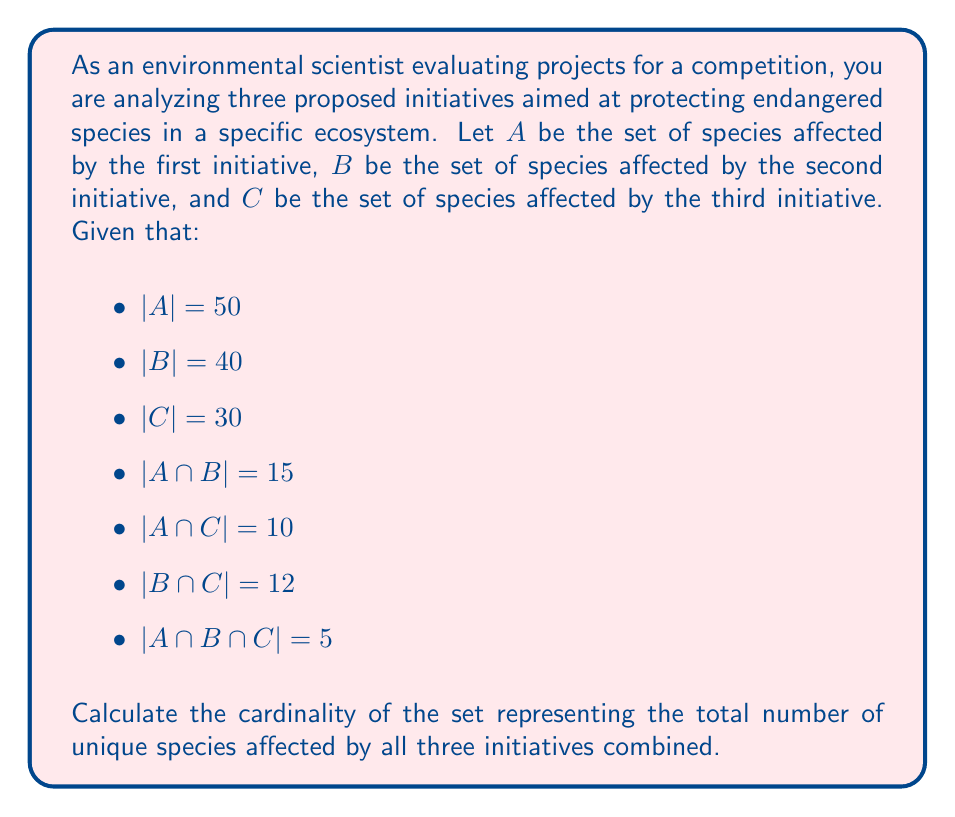Provide a solution to this math problem. To solve this problem, we need to use the principle of inclusion-exclusion for three sets. The formula for the cardinality of the union of three sets is:

$$|A \cup B \cup C| = |A| + |B| + |C| - |A \cap B| - |A \cap C| - |B \cap C| + |A \cap B \cap C|$$

Let's substitute the given values into this formula:

1. $|A| = 50$
2. $|B| = 40$
3. $|C| = 30$
4. $|A \cap B| = 15$
5. $|A \cap C| = 10$
6. $|B \cap C| = 12$
7. $|A \cap B \cap C| = 5$

Now, let's calculate:

$$\begin{align}
|A \cup B \cup C| &= 50 + 40 + 30 - 15 - 10 - 12 + 5 \\
&= 120 - 37 + 5 \\
&= 88
\end{align}$$

Therefore, the total number of unique species affected by all three initiatives combined is 88.
Answer: 88 species 